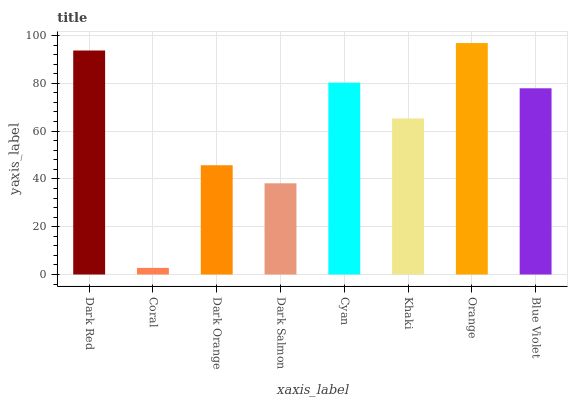Is Coral the minimum?
Answer yes or no. Yes. Is Orange the maximum?
Answer yes or no. Yes. Is Dark Orange the minimum?
Answer yes or no. No. Is Dark Orange the maximum?
Answer yes or no. No. Is Dark Orange greater than Coral?
Answer yes or no. Yes. Is Coral less than Dark Orange?
Answer yes or no. Yes. Is Coral greater than Dark Orange?
Answer yes or no. No. Is Dark Orange less than Coral?
Answer yes or no. No. Is Blue Violet the high median?
Answer yes or no. Yes. Is Khaki the low median?
Answer yes or no. Yes. Is Orange the high median?
Answer yes or no. No. Is Blue Violet the low median?
Answer yes or no. No. 